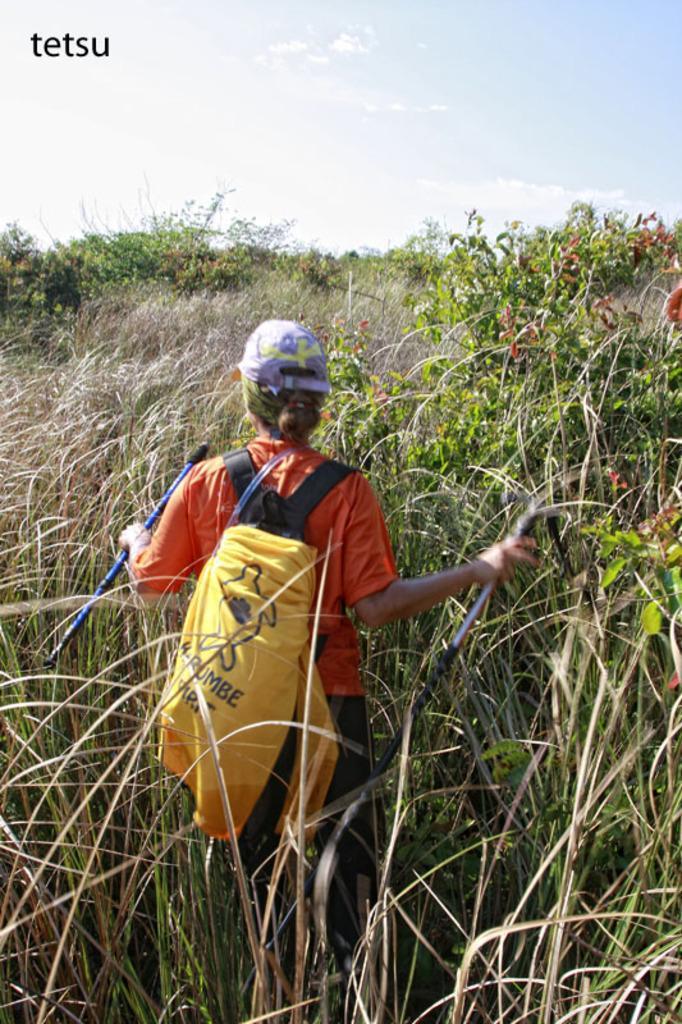Please provide a concise description of this image. In this image we can see a woman in the middle of the farm. She is wearing orange color t-shirt, purple cap, black pant and carrying bag. 